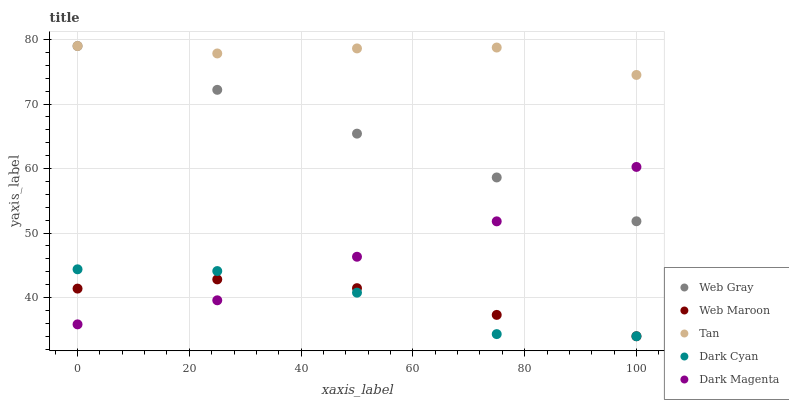Does Dark Cyan have the minimum area under the curve?
Answer yes or no. Yes. Does Tan have the maximum area under the curve?
Answer yes or no. Yes. Does Web Gray have the minimum area under the curve?
Answer yes or no. No. Does Web Gray have the maximum area under the curve?
Answer yes or no. No. Is Web Gray the smoothest?
Answer yes or no. Yes. Is Dark Cyan the roughest?
Answer yes or no. Yes. Is Tan the smoothest?
Answer yes or no. No. Is Tan the roughest?
Answer yes or no. No. Does Dark Cyan have the lowest value?
Answer yes or no. Yes. Does Web Gray have the lowest value?
Answer yes or no. No. Does Web Gray have the highest value?
Answer yes or no. Yes. Does Web Maroon have the highest value?
Answer yes or no. No. Is Dark Magenta less than Tan?
Answer yes or no. Yes. Is Tan greater than Dark Magenta?
Answer yes or no. Yes. Does Web Maroon intersect Dark Cyan?
Answer yes or no. Yes. Is Web Maroon less than Dark Cyan?
Answer yes or no. No. Is Web Maroon greater than Dark Cyan?
Answer yes or no. No. Does Dark Magenta intersect Tan?
Answer yes or no. No. 